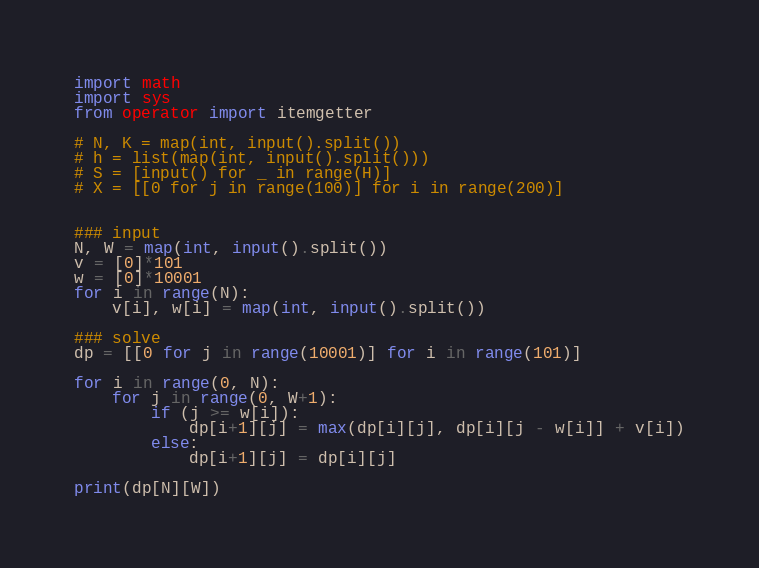Convert code to text. <code><loc_0><loc_0><loc_500><loc_500><_Python_>import math
import sys
from operator import itemgetter

# N, K = map(int, input().split())
# h = list(map(int, input().split()))
# S = [input() for _ in range(H)]
# X = [[0 for j in range(100)] for i in range(200)]


### input
N, W = map(int, input().split())
v = [0]*101
w = [0]*10001
for i in range(N):
	v[i], w[i] = map(int, input().split())

### solve
dp = [[0 for j in range(10001)] for i in range(101)]

for i in range(0, N):
	for j in range(0, W+1):
		if (j >= w[i]):
			dp[i+1][j] = max(dp[i][j], dp[i][j - w[i]] + v[i])
		else:
			dp[i+1][j] = dp[i][j]

print(dp[N][W])
</code> 